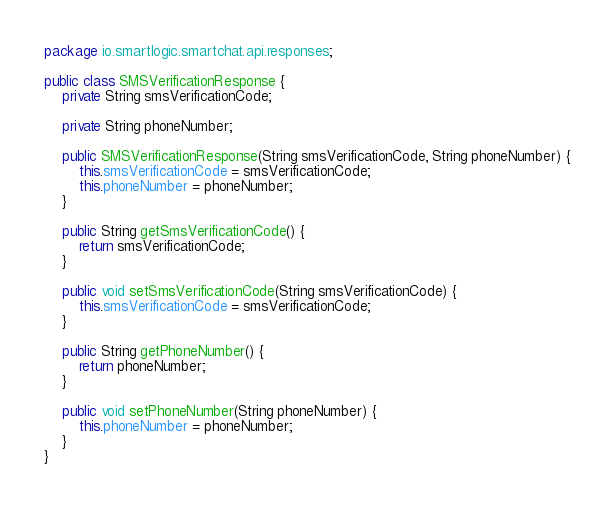Convert code to text. <code><loc_0><loc_0><loc_500><loc_500><_Java_>package io.smartlogic.smartchat.api.responses;

public class SMSVerificationResponse {
    private String smsVerificationCode;

    private String phoneNumber;

    public SMSVerificationResponse(String smsVerificationCode, String phoneNumber) {
        this.smsVerificationCode = smsVerificationCode;
        this.phoneNumber = phoneNumber;
    }

    public String getSmsVerificationCode() {
        return smsVerificationCode;
    }

    public void setSmsVerificationCode(String smsVerificationCode) {
        this.smsVerificationCode = smsVerificationCode;
    }

    public String getPhoneNumber() {
        return phoneNumber;
    }

    public void setPhoneNumber(String phoneNumber) {
        this.phoneNumber = phoneNumber;
    }
}
</code> 